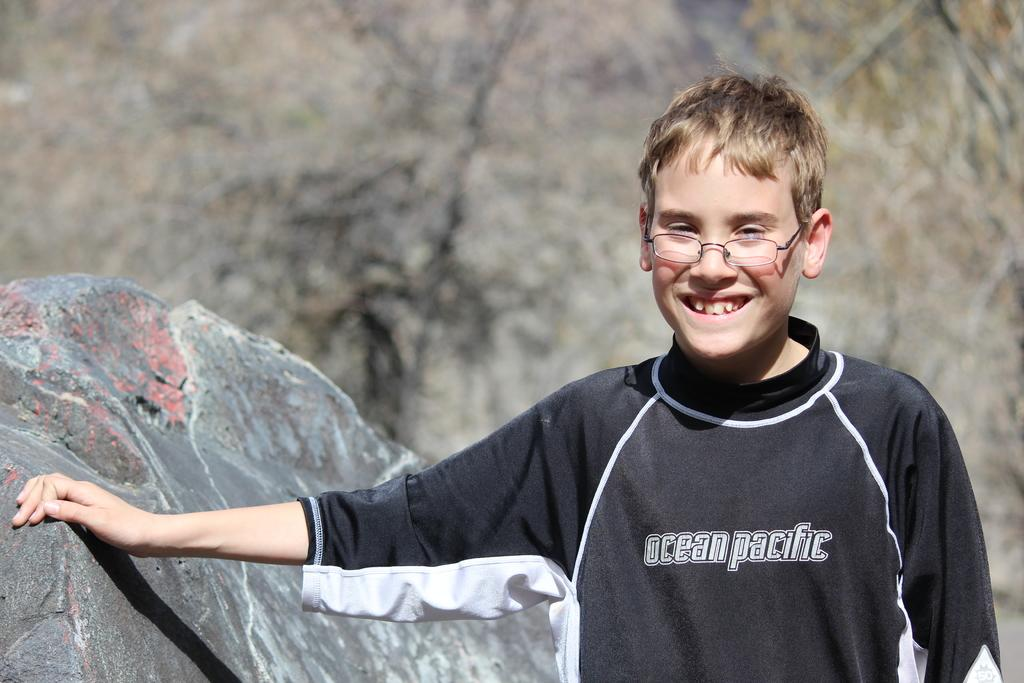<image>
Describe the image concisely. Boy posing for a picture while wearing an "Ocean Pacific" shirt. 